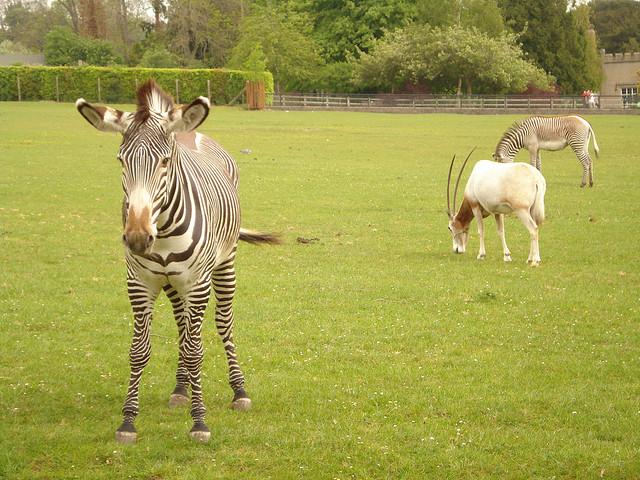What species of Zebra are in the photo?
Keep it brief. Zebra. How many zebras are in this picture?
Be succinct. 2. Are these all the same animals?
Answer briefly. No. 